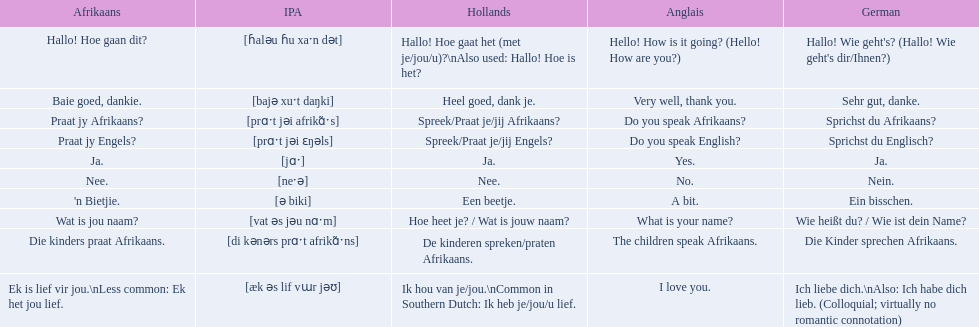How would you say the phrase the children speak afrikaans in afrikaans? Die kinders praat Afrikaans. How would you say the previous phrase in german? Die Kinder sprechen Afrikaans. 